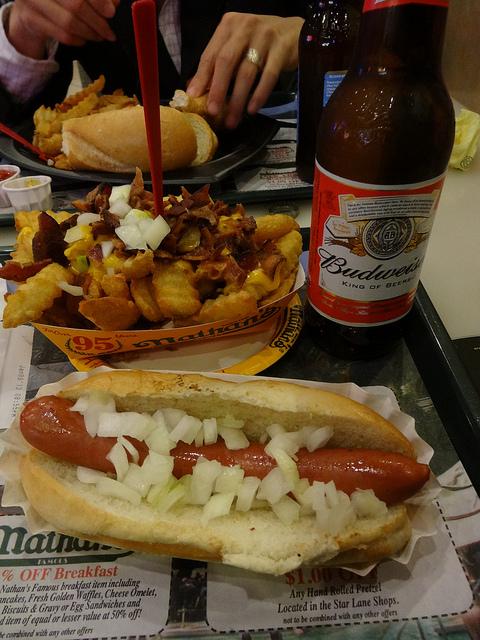What is the brand of beer?
Concise answer only. Budweiser. What condiment is on the hot dog?
Write a very short answer. Onions. How many rings are on the person's hand?
Answer briefly. 1. What drink do they have?
Short answer required. Beer. What is on top of this hot dog?
Be succinct. Onions. 